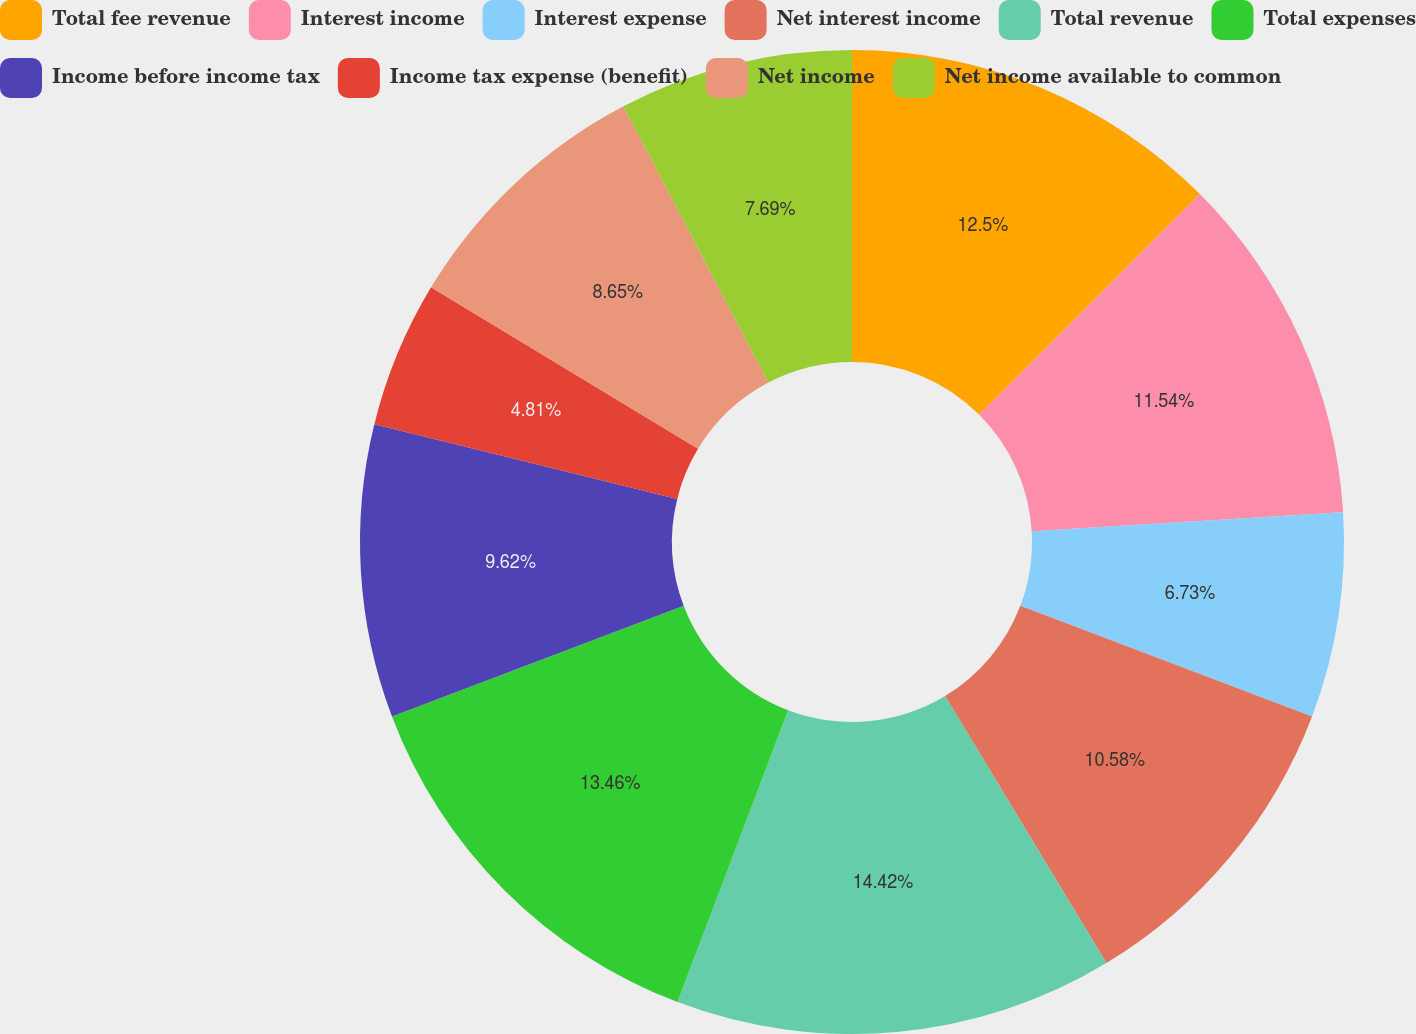Convert chart to OTSL. <chart><loc_0><loc_0><loc_500><loc_500><pie_chart><fcel>Total fee revenue<fcel>Interest income<fcel>Interest expense<fcel>Net interest income<fcel>Total revenue<fcel>Total expenses<fcel>Income before income tax<fcel>Income tax expense (benefit)<fcel>Net income<fcel>Net income available to common<nl><fcel>12.5%<fcel>11.54%<fcel>6.73%<fcel>10.58%<fcel>14.42%<fcel>13.46%<fcel>9.62%<fcel>4.81%<fcel>8.65%<fcel>7.69%<nl></chart> 